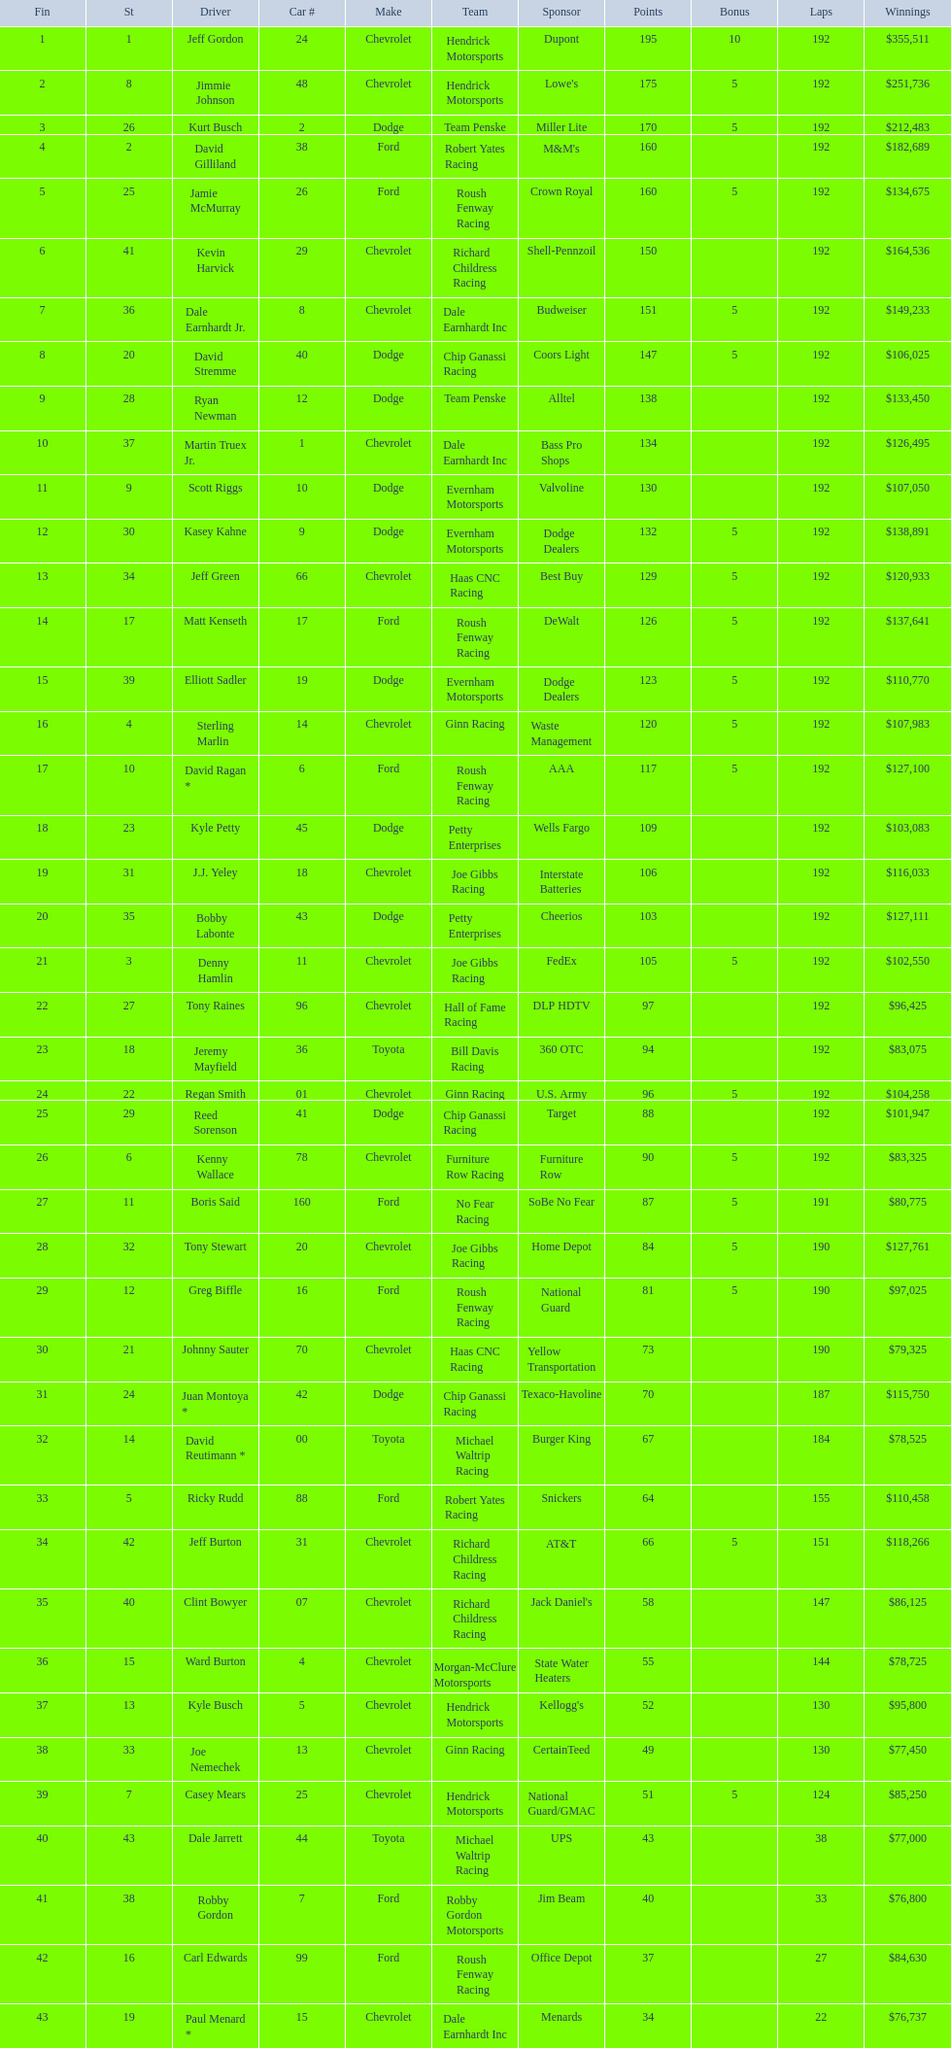For this specific race, what was the number of drivers who didn't get any bonus? 23. 